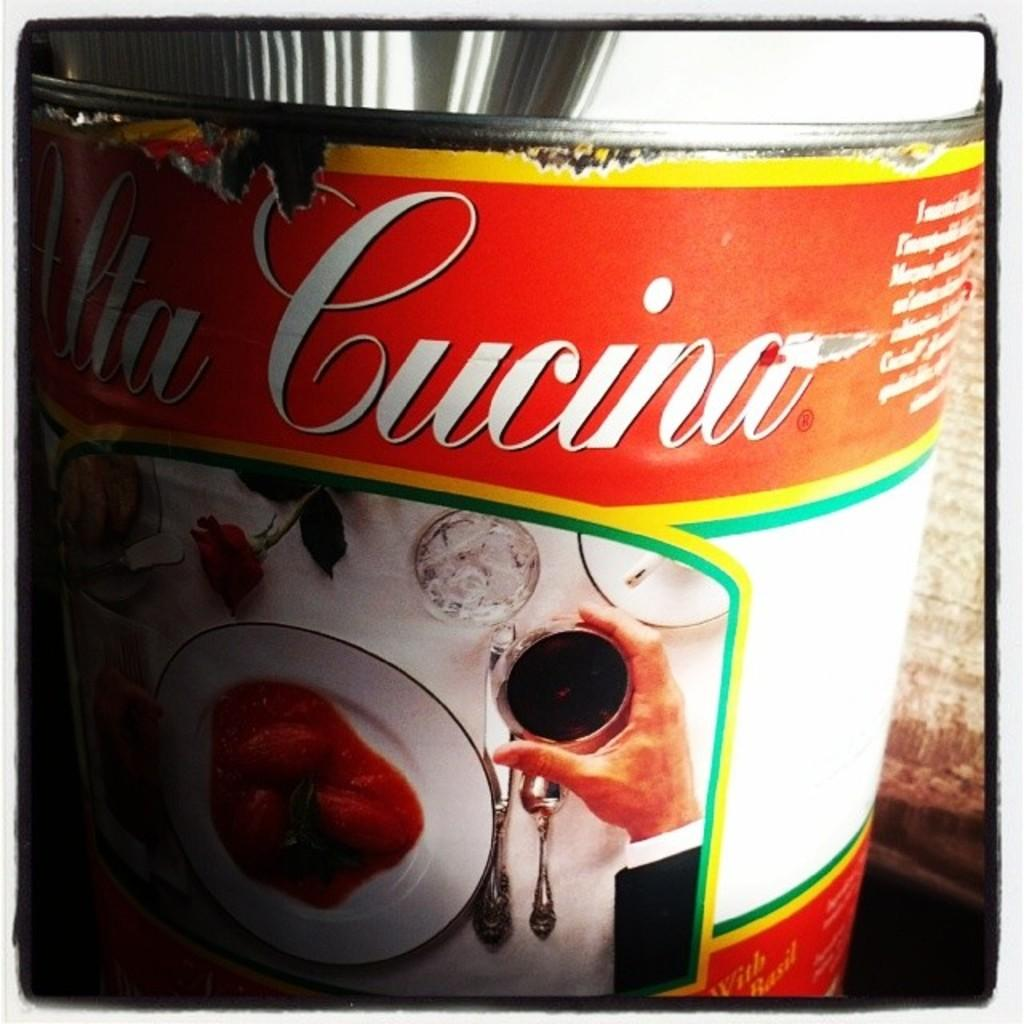<image>
Give a short and clear explanation of the subsequent image. A can which has a red and white label with the word Cucina on the top. 